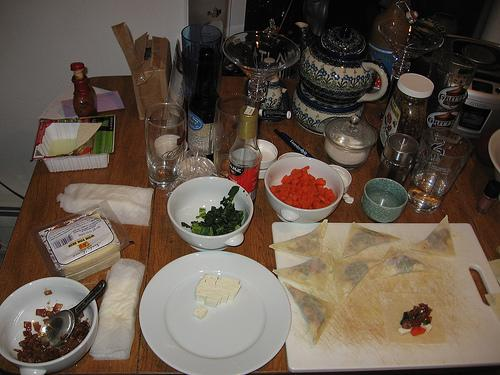Count the total number of food items presented on the wooden table. There are at least twelve different food items, including cheese, carrots, spinach, butter, onions, tomatoes, tofu, and more. How are the cheese pieces arranged on the wooden table? The cheese pieces are scattered on the wooden table, with some on a white plate and others sliced and placed elsewhere. Detect any beverages present on the table. There is no clear indication of beverages present on the table, although there are two drinking glasses and a teapot within the scene. Discuss the type of table shown in the image, as well as the items placed on it. The image features a light brown wooden table filled with various foods, dishes, utensils, and items such as a pen, a glass, a teapot, a CD player, and other objects. What types of ingredients and dishes can you identify in the image? The image presents various ingredients such as chopped carrots, spinach, green onions, red tomatoes, and cheese, alongside dishes including white plates, cutting boards, bowls, glasses, and a teapot. 